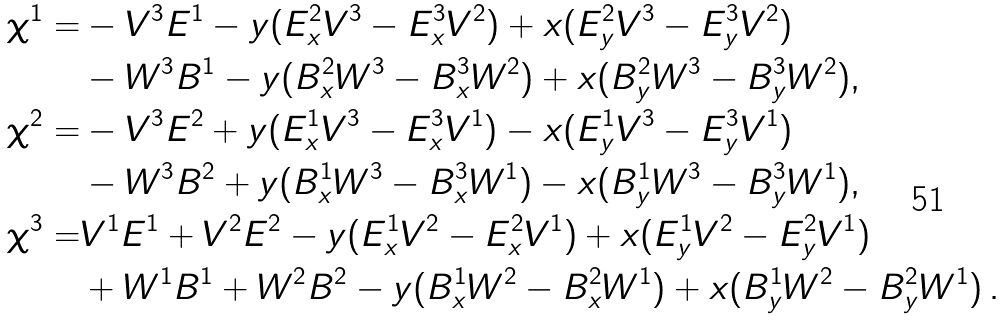<formula> <loc_0><loc_0><loc_500><loc_500>\chi ^ { 1 } = & - V ^ { 3 } E ^ { 1 } - y ( E ^ { 2 } _ { x } V ^ { 3 } - E ^ { 3 } _ { x } V ^ { 2 } ) + x ( E ^ { 2 } _ { y } V ^ { 3 } - E ^ { 3 } _ { y } V ^ { 2 } ) \\ & - W ^ { 3 } B ^ { 1 } - y ( B ^ { 2 } _ { x } W ^ { 3 } - B ^ { 3 } _ { x } W ^ { 2 } ) + x ( B ^ { 2 } _ { y } W ^ { 3 } - B ^ { 3 } _ { y } W ^ { 2 } ) , \\ \chi ^ { 2 } = & - V ^ { 3 } E ^ { 2 } + y ( E ^ { 1 } _ { x } V ^ { 3 } - E ^ { 3 } _ { x } V ^ { 1 } ) - x ( E ^ { 1 } _ { y } V ^ { 3 } - E ^ { 3 } _ { y } V ^ { 1 } ) \\ & - W ^ { 3 } B ^ { 2 } + y ( B ^ { 1 } _ { x } W ^ { 3 } - B ^ { 3 } _ { x } W ^ { 1 } ) - x ( B ^ { 1 } _ { y } W ^ { 3 } - B ^ { 3 } _ { y } W ^ { 1 } ) , \\ \chi ^ { 3 } = & V ^ { 1 } E ^ { 1 } + V ^ { 2 } E ^ { 2 } - y ( E ^ { 1 } _ { x } V ^ { 2 } - E ^ { 2 } _ { x } V ^ { 1 } ) + x ( E ^ { 1 } _ { y } V ^ { 2 } - E ^ { 2 } _ { y } V ^ { 1 } ) \\ & + W ^ { 1 } B ^ { 1 } + W ^ { 2 } B ^ { 2 } - y ( B ^ { 1 } _ { x } W ^ { 2 } - B ^ { 2 } _ { x } W ^ { 1 } ) + x ( B ^ { 1 } _ { y } W ^ { 2 } - B ^ { 2 } _ { y } W ^ { 1 } ) \, .</formula> 